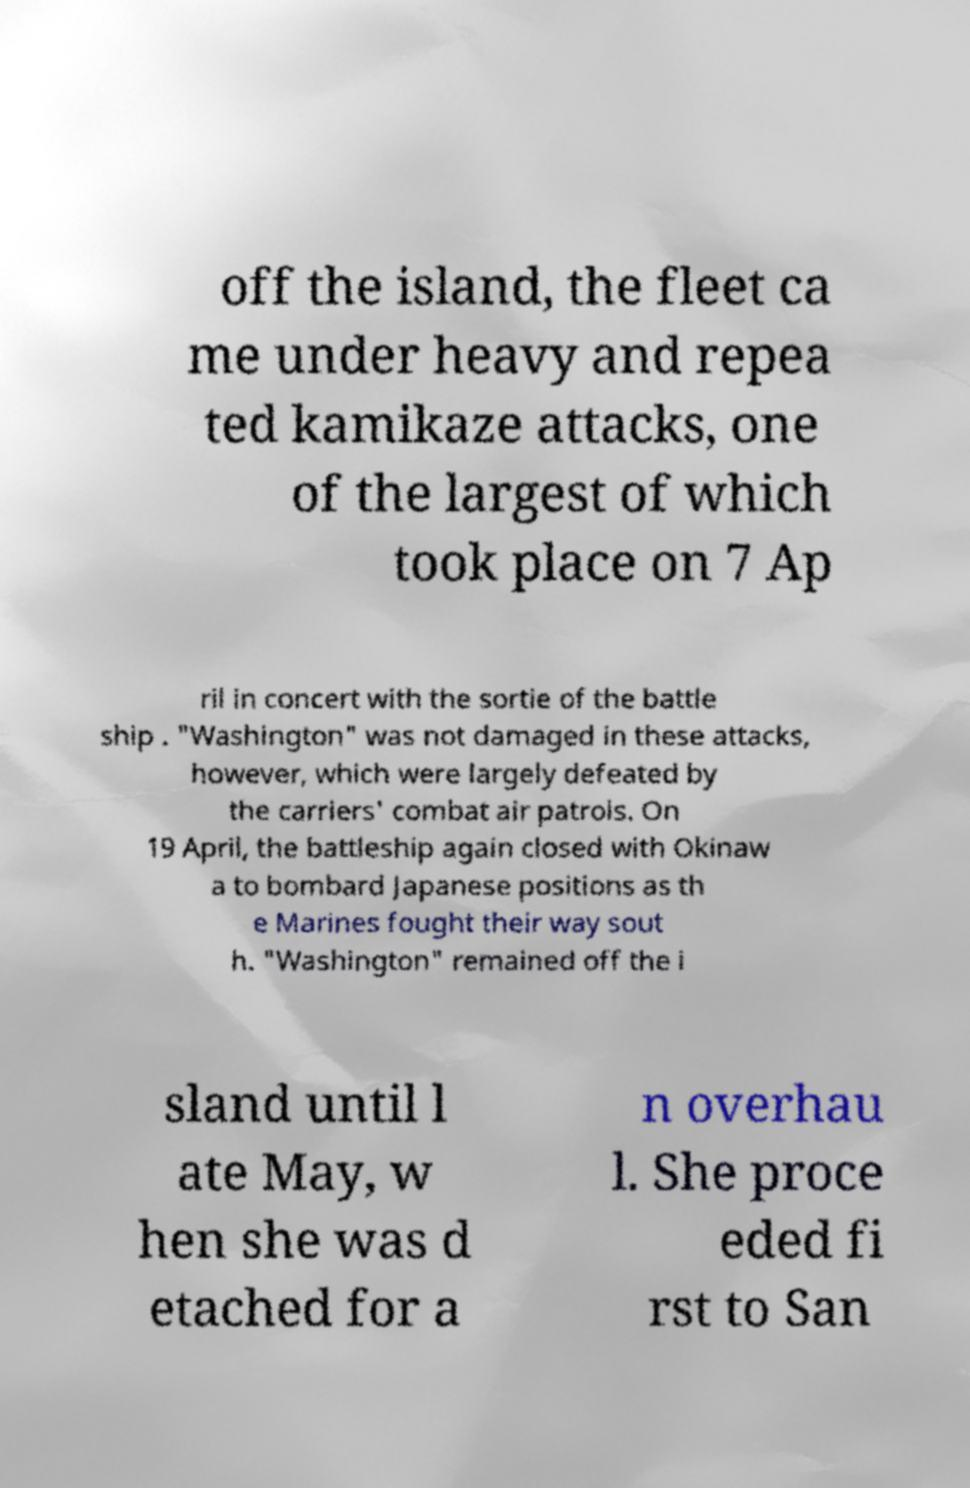Could you extract and type out the text from this image? off the island, the fleet ca me under heavy and repea ted kamikaze attacks, one of the largest of which took place on 7 Ap ril in concert with the sortie of the battle ship . "Washington" was not damaged in these attacks, however, which were largely defeated by the carriers' combat air patrols. On 19 April, the battleship again closed with Okinaw a to bombard Japanese positions as th e Marines fought their way sout h. "Washington" remained off the i sland until l ate May, w hen she was d etached for a n overhau l. She proce eded fi rst to San 